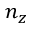Convert formula to latex. <formula><loc_0><loc_0><loc_500><loc_500>n _ { z }</formula> 